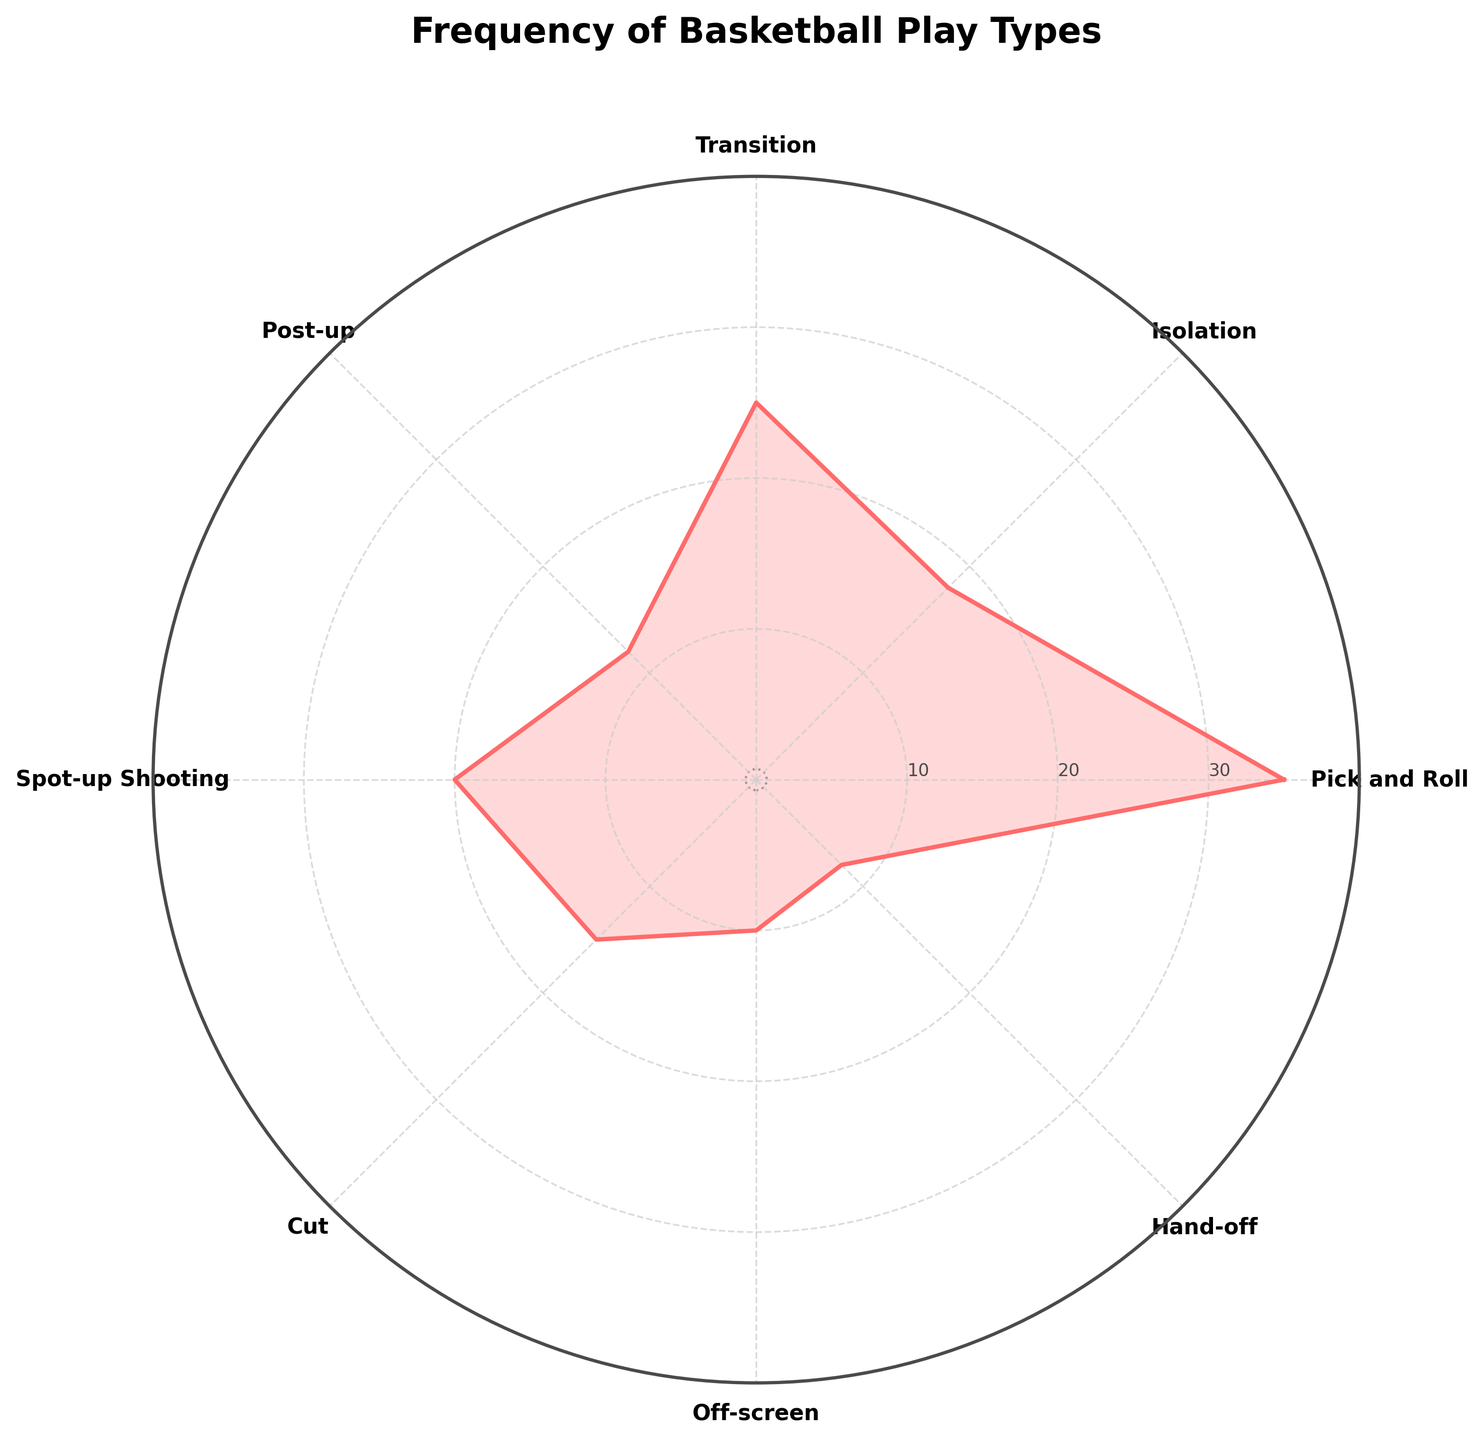What is the most frequent type of basketball play? The most frequent type of play is indicated by the longest radial line on the rose chart, which represents the highest value.
Answer: Pick and Roll How many play types are depicted in the chart? Count all distinct categories or labels displayed on the polar plot, excluding the repeated category to close the plot.
Answer: 8 What is the combined frequency of Isolation and Cut plays? Identify the values for Isolation (18) and Cut (15) then sum them up. So, 18 + 15 = 33
Answer: 33 Which play type has the least frequency, and what is its value? Locate the shortest radial line on the rose chart, which represents the smallest number in the Frequency column, and determine its label and value.
Answer: Hand-off, 8 How does the frequency of Transition compare to Spot-up Shooting? Find the values associated with Transition (25) and Spot-up Shooting (20) then compare them. 25 is greater than 20.
Answer: Transition is more frequent What is the title of the chart? The title is usually placed at the top center of the plot, above all the data points and axes.
Answer: Frequency of Basketball Play Types What is the average frequency of all play types? Sum all frequencies (35 + 18 + 25 + 12 + 20 + 15 + 10 + 8 = 143) and divide by the number of play types (8). 143 / 8 = 17.875
Answer: 17.875 What type of play is second most frequent, and what is its frequency? Identify the play type with the second longest radial line, which represents the second highest frequency.
Answer: Transition, 25 Which play types have a frequency greater than 20? Identify and list the play types with radial lines extending beyond the 20-frequency mark: Pick and Roll (35) and Transition (25).
Answer: Pick and Roll, Transition Are there any play types that share the same frequency? Compare each frequency value and determine if any are identical. None of the play types have the same frequency value.
Answer: No 